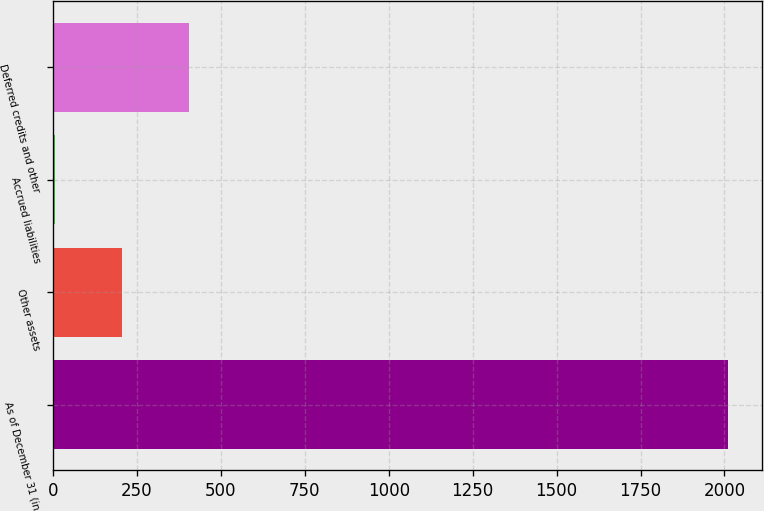<chart> <loc_0><loc_0><loc_500><loc_500><bar_chart><fcel>As of December 31 (in<fcel>Other assets<fcel>Accrued liabilities<fcel>Deferred credits and other<nl><fcel>2011<fcel>205.6<fcel>5<fcel>406.2<nl></chart> 